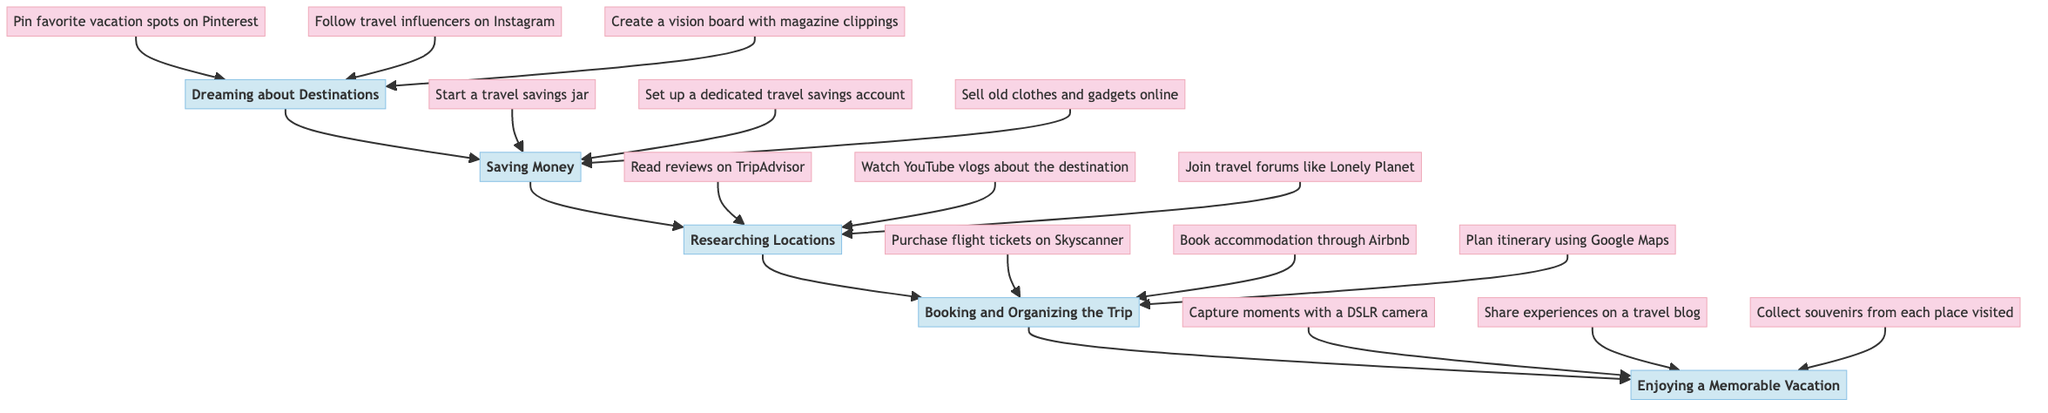What is the first step in the vacation planning process? The diagram starts with "Dreaming about Destinations," which is the first step that leads to the subsequent steps.
Answer: Dreaming about Destinations How many main steps are there in the vacation planning process? By counting the nodes vertically in the diagram, there are five main steps: Dreaming about Destinations, Saving Money, Researching Locations, Booking and Organizing the Trip, and Enjoying a Memorable Vacation.
Answer: 5 What is the last step in the flow chart? The diagram ends at "Enjoying a Memorable Vacation," which is indicated as the final destination in the flow chart.
Answer: Enjoying a Memorable Vacation Which step involves selling old clothes and gadgets? The flow chart lists "Sell old clothes and gadgets online" as part of the "Saving Money" step, indicating it is a method to save money for the vacation.
Answer: Saving Money What are three activities you can do in the "Researching Locations" step? The diagram provides specific activities under "Researching Locations," which include reading reviews on TripAdvisor, watching YouTube vlogs about the destination, and joining travel forums like Lonely Planet.
Answer: Read reviews on TripAdvisor, Watch YouTube vlogs about the destination, Join travel forums like Lonely Planet Which step follows "Booking and Organizing the Trip"? According to the flow chart, "Enjoying a Memorable Vacation" directly follows "Booking and Organizing the Trip," meaning they are adjacent in the flow of the diagram.
Answer: Enjoying a Memorable Vacation How is "Follow travel influencers on Instagram" related to the overall process? This activity is listed under the "Dreaming about Destinations" step, indicating it is one of the initial actions to inspire and motivate vacation planning.
Answer: Dreaming about Destinations Which activity is NOT part of the "Booking and Organizing the Trip" step? “Capture moments with a DSLR camera” does not belong to the "Booking and Organizing the Trip" step; rather, it is an activity in the final step, "Enjoying a Memorable Vacation."
Answer: Capturing moments with a DSLR camera How many activities are listed under the "Saving Money" step? There are three activities associated with the "Saving Money" step: starting a travel savings jar, setting up a dedicated travel savings account, and selling old clothes and gadgets online.
Answer: 3 